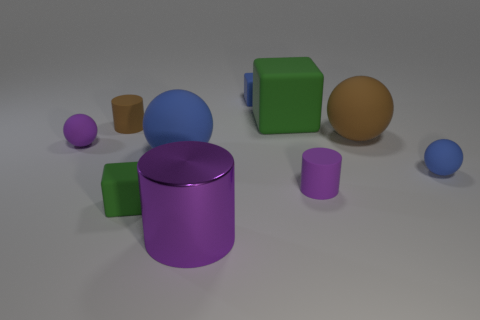Subtract all shiny cylinders. How many cylinders are left? 2 Subtract all brown cylinders. How many cylinders are left? 2 Subtract 1 cylinders. How many cylinders are left? 2 Subtract all blue cubes. Subtract all green cylinders. How many cubes are left? 2 Subtract all green cubes. How many gray cylinders are left? 0 Subtract all big brown spheres. Subtract all tiny green rubber things. How many objects are left? 8 Add 3 tiny purple matte things. How many tiny purple matte things are left? 5 Add 2 metal cylinders. How many metal cylinders exist? 3 Subtract 0 red cylinders. How many objects are left? 10 Subtract all cubes. How many objects are left? 7 